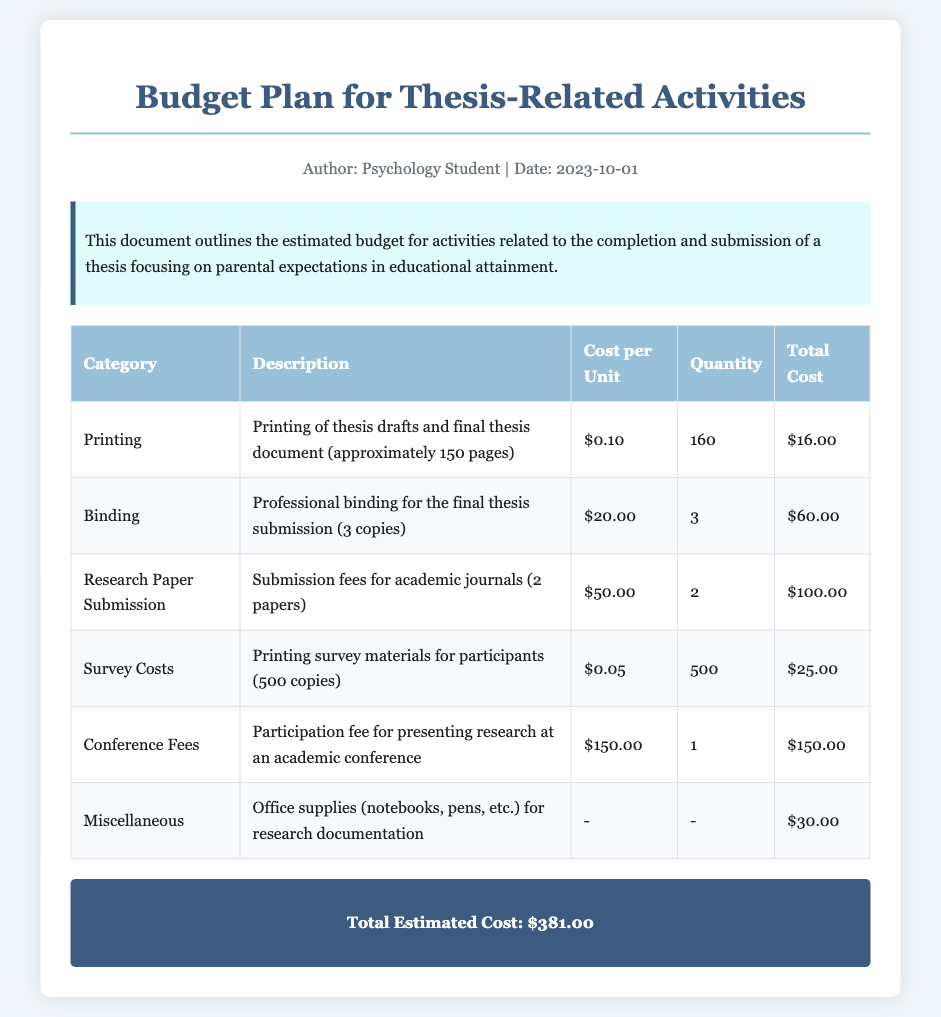What is the total estimated cost? The total estimated cost is listed in the summary section of the document.
Answer: $381.00 How many copies of the thesis will be bound? The binding section specifies the number of copies for binding.
Answer: 3 What is the cost per unit for printing? The printing section provides the cost per unit for printing thesis documents.
Answer: $0.10 How many research papers are being submitted? The research paper submission section indicates the quantity of submitted papers.
Answer: 2 What is the cost for professional binding? The binding section lists the total cost for professional binding of the thesis.
Answer: $60.00 What is the cost of survey materials printing? The survey costs section shows the total cost for printing survey materials.
Answer: $25.00 What are the miscellaneous costs for? The miscellaneous section describes the type of items covered by these costs.
Answer: Office supplies What is the participation fee for the conference? The conference fees section explicitly states the participation fee required.
Answer: $150.00 What is the total quantity of printed thesis drafts? The printing section indicates the total quantity planned for thesis drafts.
Answer: 160 